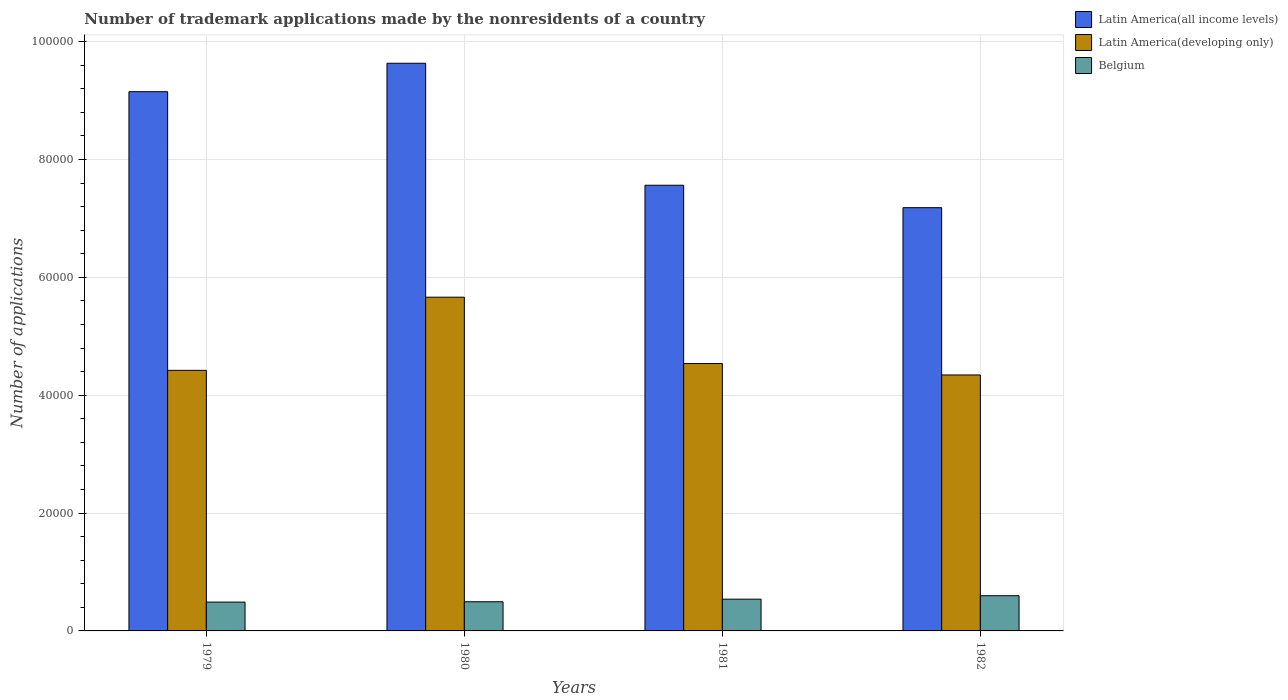How many groups of bars are there?
Ensure brevity in your answer.  4. Are the number of bars per tick equal to the number of legend labels?
Make the answer very short. Yes. How many bars are there on the 2nd tick from the right?
Make the answer very short. 3. What is the label of the 4th group of bars from the left?
Your answer should be compact. 1982. What is the number of trademark applications made by the nonresidents in Belgium in 1979?
Offer a very short reply. 4894. Across all years, what is the maximum number of trademark applications made by the nonresidents in Belgium?
Provide a short and direct response. 5973. Across all years, what is the minimum number of trademark applications made by the nonresidents in Belgium?
Keep it short and to the point. 4894. In which year was the number of trademark applications made by the nonresidents in Latin America(developing only) minimum?
Ensure brevity in your answer.  1982. What is the total number of trademark applications made by the nonresidents in Belgium in the graph?
Ensure brevity in your answer.  2.12e+04. What is the difference between the number of trademark applications made by the nonresidents in Latin America(developing only) in 1980 and that in 1981?
Ensure brevity in your answer.  1.13e+04. What is the difference between the number of trademark applications made by the nonresidents in Belgium in 1982 and the number of trademark applications made by the nonresidents in Latin America(all income levels) in 1979?
Your answer should be very brief. -8.55e+04. What is the average number of trademark applications made by the nonresidents in Latin America(developing only) per year?
Make the answer very short. 4.74e+04. In the year 1979, what is the difference between the number of trademark applications made by the nonresidents in Latin America(developing only) and number of trademark applications made by the nonresidents in Belgium?
Offer a very short reply. 3.93e+04. In how many years, is the number of trademark applications made by the nonresidents in Belgium greater than 44000?
Your response must be concise. 0. What is the ratio of the number of trademark applications made by the nonresidents in Belgium in 1979 to that in 1982?
Provide a short and direct response. 0.82. Is the difference between the number of trademark applications made by the nonresidents in Latin America(developing only) in 1979 and 1980 greater than the difference between the number of trademark applications made by the nonresidents in Belgium in 1979 and 1980?
Your response must be concise. No. What is the difference between the highest and the second highest number of trademark applications made by the nonresidents in Belgium?
Offer a very short reply. 583. What is the difference between the highest and the lowest number of trademark applications made by the nonresidents in Latin America(all income levels)?
Provide a short and direct response. 2.45e+04. Is the sum of the number of trademark applications made by the nonresidents in Latin America(all income levels) in 1980 and 1981 greater than the maximum number of trademark applications made by the nonresidents in Belgium across all years?
Provide a succinct answer. Yes. What does the 2nd bar from the left in 1982 represents?
Provide a short and direct response. Latin America(developing only). What does the 3rd bar from the right in 1979 represents?
Make the answer very short. Latin America(all income levels). What is the difference between two consecutive major ticks on the Y-axis?
Ensure brevity in your answer.  2.00e+04. Are the values on the major ticks of Y-axis written in scientific E-notation?
Offer a very short reply. No. Where does the legend appear in the graph?
Give a very brief answer. Top right. How are the legend labels stacked?
Offer a terse response. Vertical. What is the title of the graph?
Provide a short and direct response. Number of trademark applications made by the nonresidents of a country. What is the label or title of the X-axis?
Provide a short and direct response. Years. What is the label or title of the Y-axis?
Offer a very short reply. Number of applications. What is the Number of applications in Latin America(all income levels) in 1979?
Keep it short and to the point. 9.15e+04. What is the Number of applications of Latin America(developing only) in 1979?
Offer a terse response. 4.42e+04. What is the Number of applications in Belgium in 1979?
Make the answer very short. 4894. What is the Number of applications in Latin America(all income levels) in 1980?
Your answer should be very brief. 9.63e+04. What is the Number of applications in Latin America(developing only) in 1980?
Ensure brevity in your answer.  5.66e+04. What is the Number of applications in Belgium in 1980?
Offer a very short reply. 4949. What is the Number of applications of Latin America(all income levels) in 1981?
Provide a short and direct response. 7.56e+04. What is the Number of applications in Latin America(developing only) in 1981?
Ensure brevity in your answer.  4.54e+04. What is the Number of applications of Belgium in 1981?
Your response must be concise. 5390. What is the Number of applications of Latin America(all income levels) in 1982?
Your answer should be compact. 7.18e+04. What is the Number of applications of Latin America(developing only) in 1982?
Provide a succinct answer. 4.34e+04. What is the Number of applications of Belgium in 1982?
Ensure brevity in your answer.  5973. Across all years, what is the maximum Number of applications of Latin America(all income levels)?
Offer a terse response. 9.63e+04. Across all years, what is the maximum Number of applications in Latin America(developing only)?
Offer a terse response. 5.66e+04. Across all years, what is the maximum Number of applications in Belgium?
Your answer should be very brief. 5973. Across all years, what is the minimum Number of applications in Latin America(all income levels)?
Ensure brevity in your answer.  7.18e+04. Across all years, what is the minimum Number of applications in Latin America(developing only)?
Offer a very short reply. 4.34e+04. Across all years, what is the minimum Number of applications in Belgium?
Provide a short and direct response. 4894. What is the total Number of applications in Latin America(all income levels) in the graph?
Keep it short and to the point. 3.35e+05. What is the total Number of applications in Latin America(developing only) in the graph?
Ensure brevity in your answer.  1.90e+05. What is the total Number of applications of Belgium in the graph?
Make the answer very short. 2.12e+04. What is the difference between the Number of applications in Latin America(all income levels) in 1979 and that in 1980?
Provide a short and direct response. -4826. What is the difference between the Number of applications in Latin America(developing only) in 1979 and that in 1980?
Keep it short and to the point. -1.24e+04. What is the difference between the Number of applications of Belgium in 1979 and that in 1980?
Offer a very short reply. -55. What is the difference between the Number of applications in Latin America(all income levels) in 1979 and that in 1981?
Your answer should be compact. 1.59e+04. What is the difference between the Number of applications in Latin America(developing only) in 1979 and that in 1981?
Offer a terse response. -1155. What is the difference between the Number of applications of Belgium in 1979 and that in 1981?
Keep it short and to the point. -496. What is the difference between the Number of applications in Latin America(all income levels) in 1979 and that in 1982?
Your answer should be compact. 1.97e+04. What is the difference between the Number of applications in Latin America(developing only) in 1979 and that in 1982?
Provide a short and direct response. 781. What is the difference between the Number of applications in Belgium in 1979 and that in 1982?
Your answer should be very brief. -1079. What is the difference between the Number of applications in Latin America(all income levels) in 1980 and that in 1981?
Give a very brief answer. 2.07e+04. What is the difference between the Number of applications in Latin America(developing only) in 1980 and that in 1981?
Offer a terse response. 1.13e+04. What is the difference between the Number of applications of Belgium in 1980 and that in 1981?
Keep it short and to the point. -441. What is the difference between the Number of applications of Latin America(all income levels) in 1980 and that in 1982?
Give a very brief answer. 2.45e+04. What is the difference between the Number of applications of Latin America(developing only) in 1980 and that in 1982?
Your response must be concise. 1.32e+04. What is the difference between the Number of applications of Belgium in 1980 and that in 1982?
Offer a very short reply. -1024. What is the difference between the Number of applications in Latin America(all income levels) in 1981 and that in 1982?
Keep it short and to the point. 3808. What is the difference between the Number of applications in Latin America(developing only) in 1981 and that in 1982?
Offer a terse response. 1936. What is the difference between the Number of applications of Belgium in 1981 and that in 1982?
Provide a short and direct response. -583. What is the difference between the Number of applications in Latin America(all income levels) in 1979 and the Number of applications in Latin America(developing only) in 1980?
Provide a short and direct response. 3.49e+04. What is the difference between the Number of applications in Latin America(all income levels) in 1979 and the Number of applications in Belgium in 1980?
Keep it short and to the point. 8.66e+04. What is the difference between the Number of applications in Latin America(developing only) in 1979 and the Number of applications in Belgium in 1980?
Offer a very short reply. 3.93e+04. What is the difference between the Number of applications in Latin America(all income levels) in 1979 and the Number of applications in Latin America(developing only) in 1981?
Offer a terse response. 4.61e+04. What is the difference between the Number of applications of Latin America(all income levels) in 1979 and the Number of applications of Belgium in 1981?
Provide a short and direct response. 8.61e+04. What is the difference between the Number of applications of Latin America(developing only) in 1979 and the Number of applications of Belgium in 1981?
Keep it short and to the point. 3.88e+04. What is the difference between the Number of applications in Latin America(all income levels) in 1979 and the Number of applications in Latin America(developing only) in 1982?
Provide a short and direct response. 4.81e+04. What is the difference between the Number of applications of Latin America(all income levels) in 1979 and the Number of applications of Belgium in 1982?
Provide a succinct answer. 8.55e+04. What is the difference between the Number of applications of Latin America(developing only) in 1979 and the Number of applications of Belgium in 1982?
Make the answer very short. 3.83e+04. What is the difference between the Number of applications in Latin America(all income levels) in 1980 and the Number of applications in Latin America(developing only) in 1981?
Give a very brief answer. 5.10e+04. What is the difference between the Number of applications of Latin America(all income levels) in 1980 and the Number of applications of Belgium in 1981?
Offer a very short reply. 9.10e+04. What is the difference between the Number of applications in Latin America(developing only) in 1980 and the Number of applications in Belgium in 1981?
Provide a short and direct response. 5.13e+04. What is the difference between the Number of applications in Latin America(all income levels) in 1980 and the Number of applications in Latin America(developing only) in 1982?
Provide a succinct answer. 5.29e+04. What is the difference between the Number of applications of Latin America(all income levels) in 1980 and the Number of applications of Belgium in 1982?
Provide a short and direct response. 9.04e+04. What is the difference between the Number of applications in Latin America(developing only) in 1980 and the Number of applications in Belgium in 1982?
Give a very brief answer. 5.07e+04. What is the difference between the Number of applications of Latin America(all income levels) in 1981 and the Number of applications of Latin America(developing only) in 1982?
Offer a terse response. 3.22e+04. What is the difference between the Number of applications in Latin America(all income levels) in 1981 and the Number of applications in Belgium in 1982?
Ensure brevity in your answer.  6.97e+04. What is the difference between the Number of applications in Latin America(developing only) in 1981 and the Number of applications in Belgium in 1982?
Provide a succinct answer. 3.94e+04. What is the average Number of applications of Latin America(all income levels) per year?
Keep it short and to the point. 8.38e+04. What is the average Number of applications in Latin America(developing only) per year?
Offer a very short reply. 4.74e+04. What is the average Number of applications of Belgium per year?
Keep it short and to the point. 5301.5. In the year 1979, what is the difference between the Number of applications in Latin America(all income levels) and Number of applications in Latin America(developing only)?
Offer a very short reply. 4.73e+04. In the year 1979, what is the difference between the Number of applications in Latin America(all income levels) and Number of applications in Belgium?
Ensure brevity in your answer.  8.66e+04. In the year 1979, what is the difference between the Number of applications in Latin America(developing only) and Number of applications in Belgium?
Keep it short and to the point. 3.93e+04. In the year 1980, what is the difference between the Number of applications of Latin America(all income levels) and Number of applications of Latin America(developing only)?
Offer a very short reply. 3.97e+04. In the year 1980, what is the difference between the Number of applications in Latin America(all income levels) and Number of applications in Belgium?
Keep it short and to the point. 9.14e+04. In the year 1980, what is the difference between the Number of applications in Latin America(developing only) and Number of applications in Belgium?
Ensure brevity in your answer.  5.17e+04. In the year 1981, what is the difference between the Number of applications in Latin America(all income levels) and Number of applications in Latin America(developing only)?
Provide a succinct answer. 3.03e+04. In the year 1981, what is the difference between the Number of applications in Latin America(all income levels) and Number of applications in Belgium?
Your response must be concise. 7.02e+04. In the year 1981, what is the difference between the Number of applications in Latin America(developing only) and Number of applications in Belgium?
Provide a succinct answer. 4.00e+04. In the year 1982, what is the difference between the Number of applications in Latin America(all income levels) and Number of applications in Latin America(developing only)?
Keep it short and to the point. 2.84e+04. In the year 1982, what is the difference between the Number of applications in Latin America(all income levels) and Number of applications in Belgium?
Ensure brevity in your answer.  6.59e+04. In the year 1982, what is the difference between the Number of applications of Latin America(developing only) and Number of applications of Belgium?
Make the answer very short. 3.75e+04. What is the ratio of the Number of applications in Latin America(all income levels) in 1979 to that in 1980?
Offer a very short reply. 0.95. What is the ratio of the Number of applications in Latin America(developing only) in 1979 to that in 1980?
Provide a short and direct response. 0.78. What is the ratio of the Number of applications of Belgium in 1979 to that in 1980?
Keep it short and to the point. 0.99. What is the ratio of the Number of applications in Latin America(all income levels) in 1979 to that in 1981?
Keep it short and to the point. 1.21. What is the ratio of the Number of applications in Latin America(developing only) in 1979 to that in 1981?
Provide a short and direct response. 0.97. What is the ratio of the Number of applications of Belgium in 1979 to that in 1981?
Provide a short and direct response. 0.91. What is the ratio of the Number of applications in Latin America(all income levels) in 1979 to that in 1982?
Make the answer very short. 1.27. What is the ratio of the Number of applications in Latin America(developing only) in 1979 to that in 1982?
Provide a succinct answer. 1.02. What is the ratio of the Number of applications of Belgium in 1979 to that in 1982?
Keep it short and to the point. 0.82. What is the ratio of the Number of applications of Latin America(all income levels) in 1980 to that in 1981?
Give a very brief answer. 1.27. What is the ratio of the Number of applications of Latin America(developing only) in 1980 to that in 1981?
Your answer should be very brief. 1.25. What is the ratio of the Number of applications of Belgium in 1980 to that in 1981?
Provide a succinct answer. 0.92. What is the ratio of the Number of applications of Latin America(all income levels) in 1980 to that in 1982?
Provide a short and direct response. 1.34. What is the ratio of the Number of applications in Latin America(developing only) in 1980 to that in 1982?
Ensure brevity in your answer.  1.3. What is the ratio of the Number of applications in Belgium in 1980 to that in 1982?
Provide a short and direct response. 0.83. What is the ratio of the Number of applications in Latin America(all income levels) in 1981 to that in 1982?
Provide a short and direct response. 1.05. What is the ratio of the Number of applications of Latin America(developing only) in 1981 to that in 1982?
Provide a succinct answer. 1.04. What is the ratio of the Number of applications of Belgium in 1981 to that in 1982?
Ensure brevity in your answer.  0.9. What is the difference between the highest and the second highest Number of applications of Latin America(all income levels)?
Your answer should be compact. 4826. What is the difference between the highest and the second highest Number of applications of Latin America(developing only)?
Keep it short and to the point. 1.13e+04. What is the difference between the highest and the second highest Number of applications of Belgium?
Your answer should be very brief. 583. What is the difference between the highest and the lowest Number of applications of Latin America(all income levels)?
Your response must be concise. 2.45e+04. What is the difference between the highest and the lowest Number of applications of Latin America(developing only)?
Offer a very short reply. 1.32e+04. What is the difference between the highest and the lowest Number of applications of Belgium?
Provide a succinct answer. 1079. 